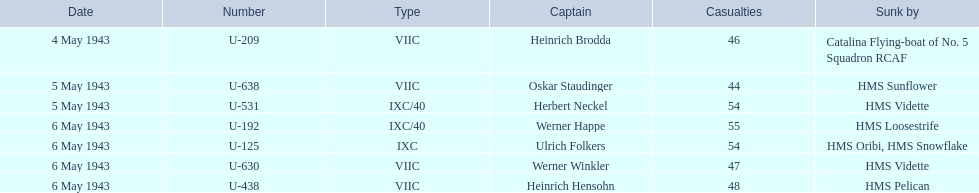What were the names of those who sank the convoys? Catalina Flying-boat of No. 5 Squadron RCAF, HMS Sunflower, HMS Vidette, HMS Loosestrife, HMS Oribi, HMS Snowflake, HMS Vidette, HMS Pelican. Which captain met their demise at the hands of the hms pelican? Heinrich Hensohn. 